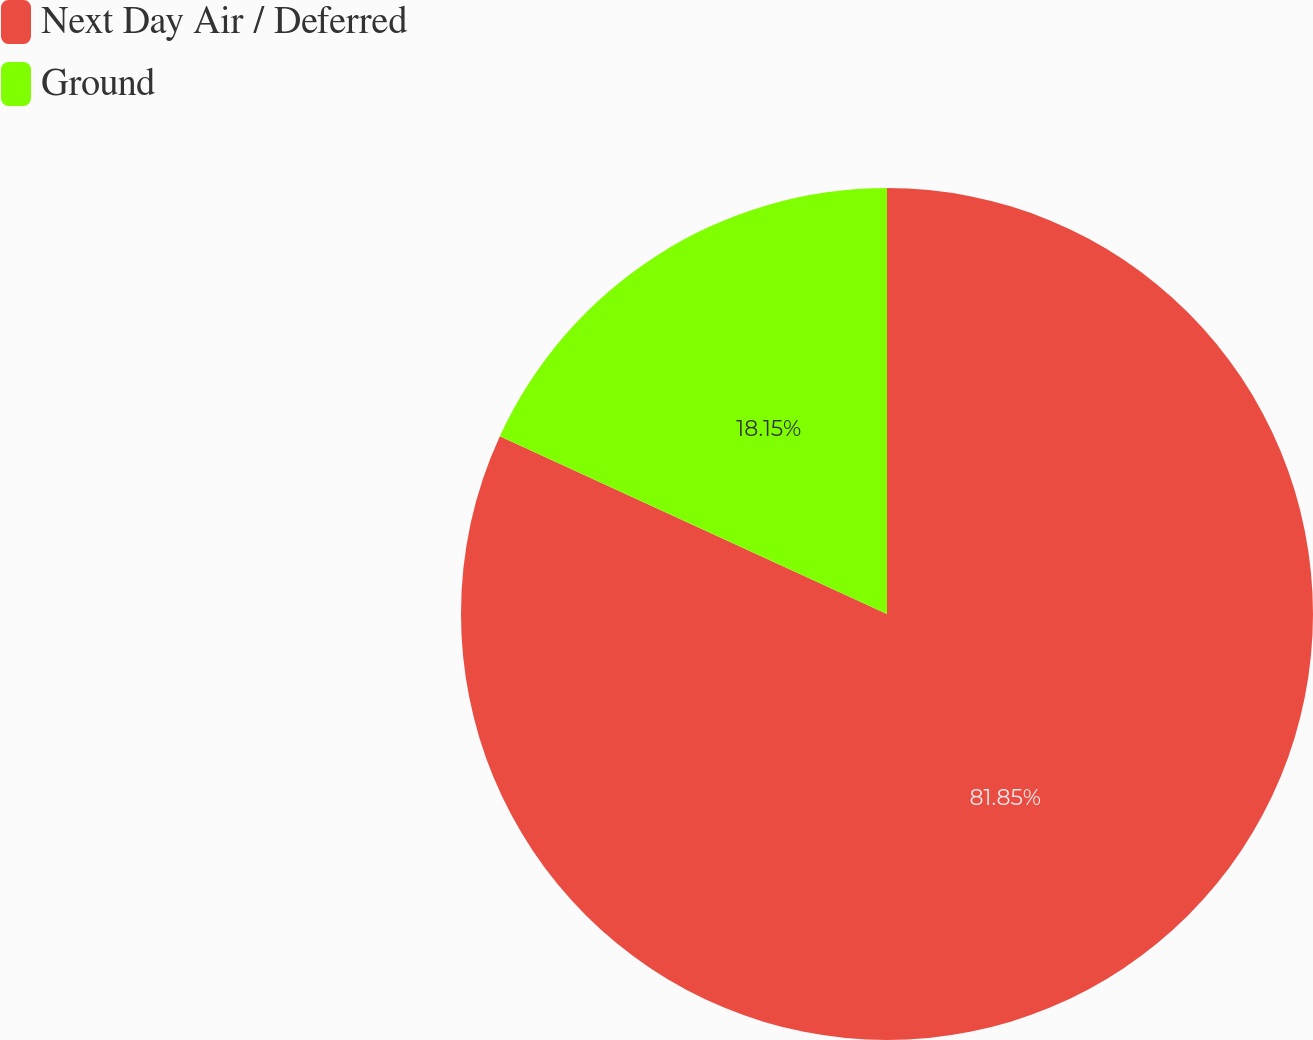Convert chart. <chart><loc_0><loc_0><loc_500><loc_500><pie_chart><fcel>Next Day Air / Deferred<fcel>Ground<nl><fcel>81.85%<fcel>18.15%<nl></chart> 